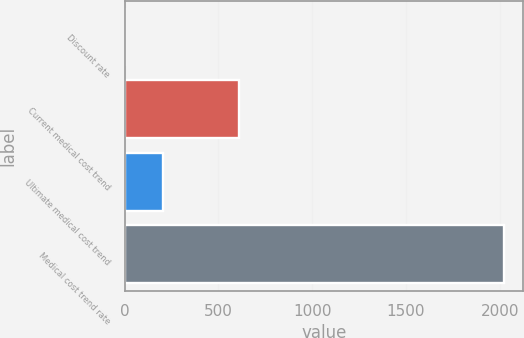Convert chart to OTSL. <chart><loc_0><loc_0><loc_500><loc_500><bar_chart><fcel>Discount rate<fcel>Current medical cost trend<fcel>Ultimate medical cost trend<fcel>Medical cost trend rate<nl><fcel>3.46<fcel>609.91<fcel>205.61<fcel>2025<nl></chart> 